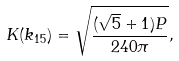<formula> <loc_0><loc_0><loc_500><loc_500>K ( k _ { 1 5 } ) = \sqrt { \frac { ( \sqrt { 5 } + 1 ) P } { 2 4 0 \pi } } ,</formula> 